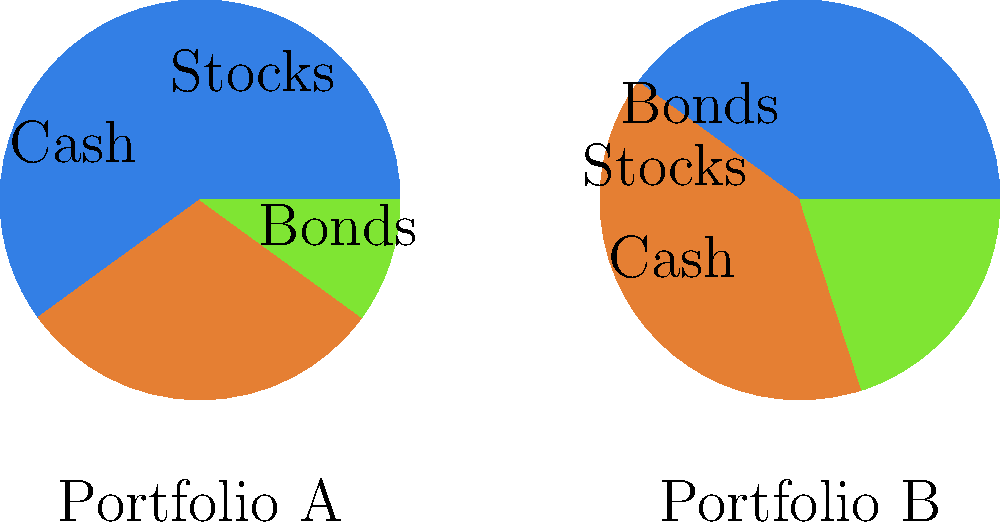As a risk-averse customer, which investment portfolio allocation would you prefer, and why? To determine the preferred portfolio for a risk-averse customer, we need to analyze both portfolios in terms of risk and potential returns:

1. Portfolio A:
   - 60% Stocks
   - 30% Bonds
   - 10% Cash

2. Portfolio B:
   - 40% Stocks
   - 40% Bonds
   - 20% Cash

Step 1: Assess risk levels
- Stocks are generally considered the riskiest asset class among the three.
- Bonds are moderately risky but less volatile than stocks.
- Cash is the least risky but offers the lowest potential returns.

Step 2: Compare stock allocations
- Portfolio A has 60% in stocks, while Portfolio B has 40%.
- A higher stock allocation implies higher risk and potentially higher returns.

Step 3: Compare bond allocations
- Portfolio A has 30% in bonds, while Portfolio B has 40%.
- A higher bond allocation provides more stability and income.

Step 4: Compare cash allocations
- Portfolio A has 10% in cash, while Portfolio B has 20%.
- A higher cash allocation offers more liquidity and lower risk.

Step 5: Consider the risk-averse profile
- A risk-averse investor prefers stability and lower volatility over potentially higher returns.
- They prioritize capital preservation and steady income.

Given these factors, Portfolio B would be more suitable for a risk-averse customer because:
1. It has a lower allocation to stocks (40% vs. 60%), reducing overall portfolio volatility.
2. It has a higher allocation to bonds (40% vs. 30%), providing more stable income and lower risk.
3. It has a higher cash allocation (20% vs. 10%), offering more liquidity and capital preservation.

While Portfolio B may have lower potential returns compared to Portfolio A, it aligns better with the risk-averse profile by offering a more balanced and conservative approach to investing.
Answer: Portfolio B, due to lower stock allocation and higher bond and cash allocations. 